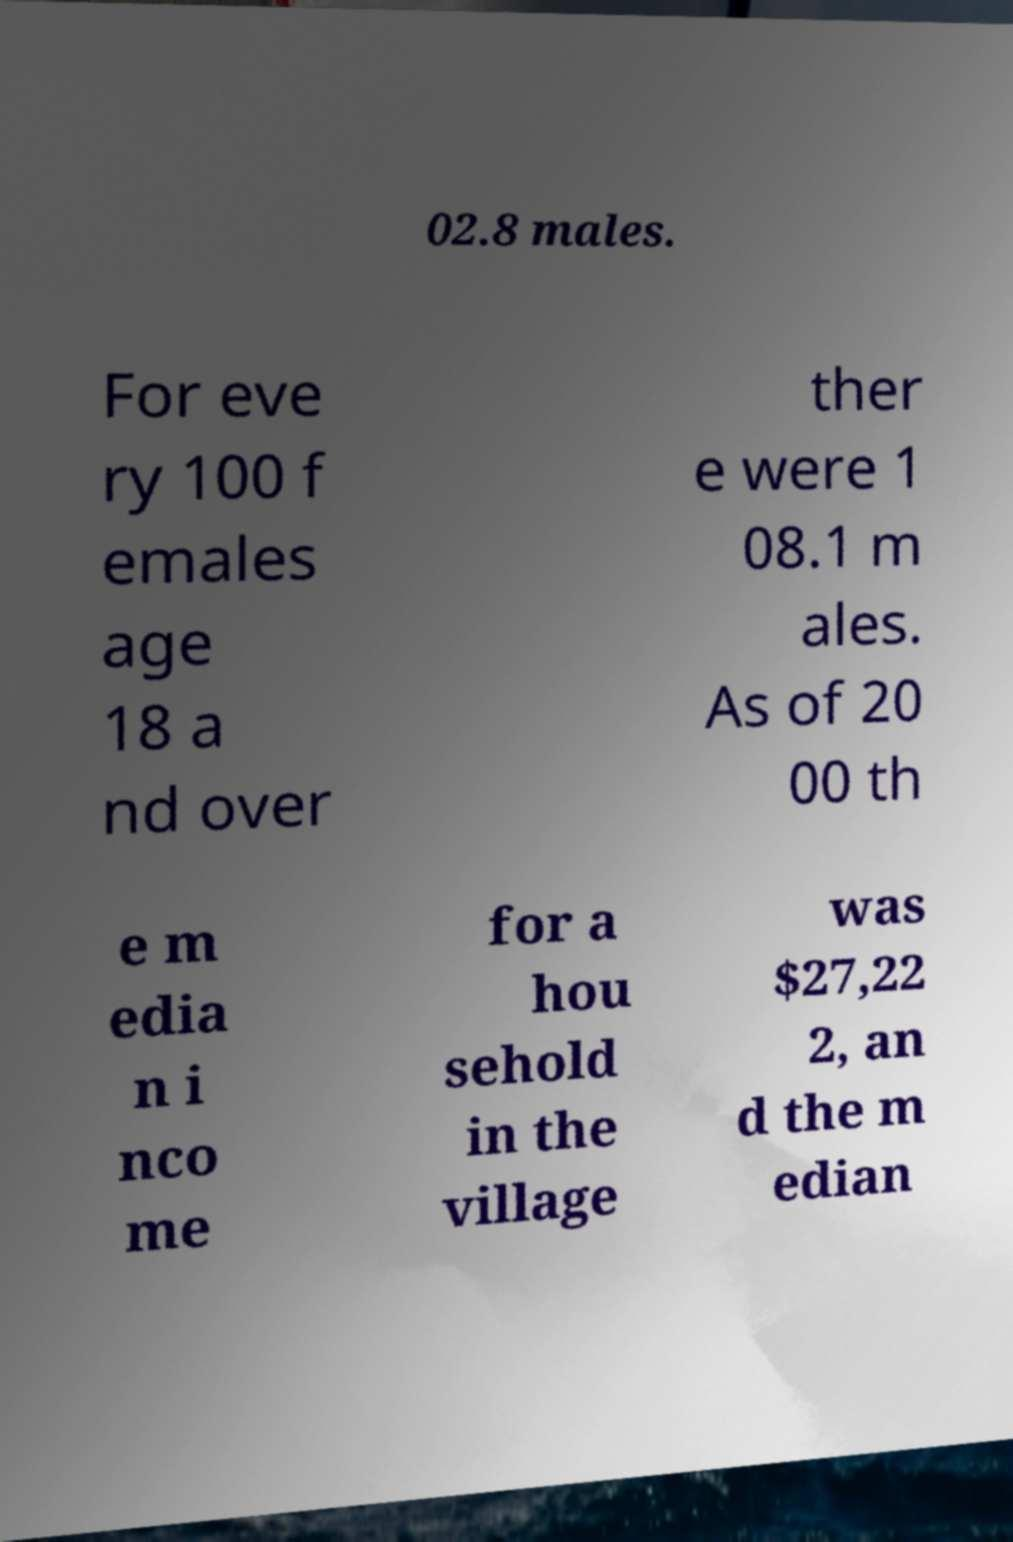For documentation purposes, I need the text within this image transcribed. Could you provide that? 02.8 males. For eve ry 100 f emales age 18 a nd over ther e were 1 08.1 m ales. As of 20 00 th e m edia n i nco me for a hou sehold in the village was $27,22 2, an d the m edian 